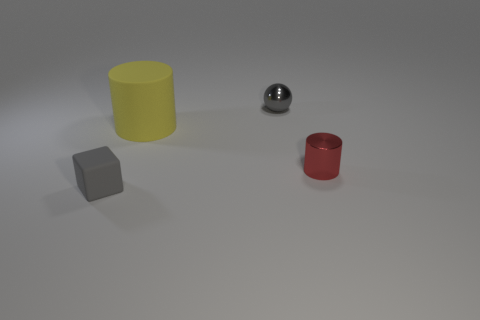Add 3 tiny red metallic objects. How many objects exist? 7 Subtract all yellow cylinders. How many cylinders are left? 1 Subtract 1 cylinders. How many cylinders are left? 1 Subtract all cubes. How many objects are left? 3 Subtract all brown cubes. Subtract all red balls. How many cubes are left? 1 Subtract all small cyan rubber cylinders. Subtract all big yellow matte things. How many objects are left? 3 Add 1 gray rubber cubes. How many gray rubber cubes are left? 2 Add 2 rubber cylinders. How many rubber cylinders exist? 3 Subtract 0 brown balls. How many objects are left? 4 